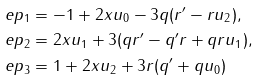<formula> <loc_0><loc_0><loc_500><loc_500>\ e p _ { 1 } & = - 1 + 2 x u _ { 0 } - 3 q ( r ^ { \prime } - r u _ { 2 } ) , \\ \ e p _ { 2 } & = 2 x u _ { 1 } + 3 ( q r ^ { \prime } - q ^ { \prime } r + q r u _ { 1 } ) , \\ \ e p _ { 3 } & = 1 + 2 x u _ { 2 } + 3 r ( q ^ { \prime } + q u _ { 0 } )</formula> 